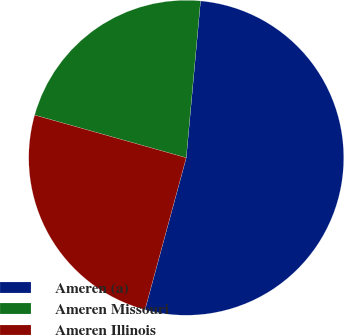Convert chart to OTSL. <chart><loc_0><loc_0><loc_500><loc_500><pie_chart><fcel>Ameren (a)<fcel>Ameren Missouri<fcel>Ameren Illinois<nl><fcel>52.77%<fcel>22.08%<fcel>25.15%<nl></chart> 